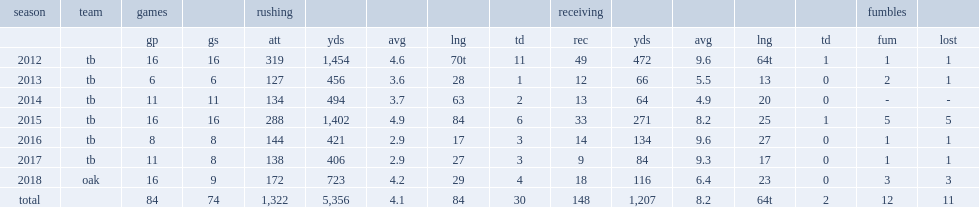How many rushing yards did doug martin get in 2014? 494.0. 